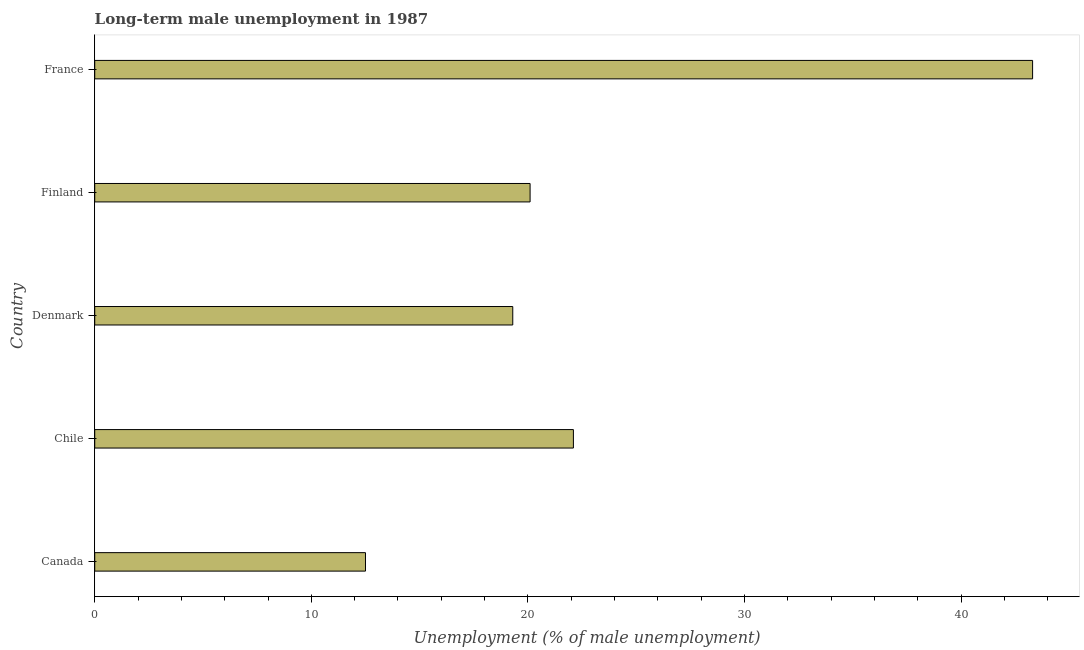Does the graph contain grids?
Your answer should be very brief. No. What is the title of the graph?
Provide a succinct answer. Long-term male unemployment in 1987. What is the label or title of the X-axis?
Provide a short and direct response. Unemployment (% of male unemployment). What is the long-term male unemployment in France?
Make the answer very short. 43.3. Across all countries, what is the maximum long-term male unemployment?
Offer a very short reply. 43.3. Across all countries, what is the minimum long-term male unemployment?
Your response must be concise. 12.5. In which country was the long-term male unemployment minimum?
Give a very brief answer. Canada. What is the sum of the long-term male unemployment?
Keep it short and to the point. 117.3. What is the difference between the long-term male unemployment in Finland and France?
Provide a short and direct response. -23.2. What is the average long-term male unemployment per country?
Offer a very short reply. 23.46. What is the median long-term male unemployment?
Offer a very short reply. 20.1. What is the ratio of the long-term male unemployment in Finland to that in France?
Ensure brevity in your answer.  0.46. Is the long-term male unemployment in Finland less than that in France?
Make the answer very short. Yes. What is the difference between the highest and the second highest long-term male unemployment?
Give a very brief answer. 21.2. What is the difference between the highest and the lowest long-term male unemployment?
Keep it short and to the point. 30.8. How many bars are there?
Your answer should be very brief. 5. How many countries are there in the graph?
Your answer should be compact. 5. What is the difference between two consecutive major ticks on the X-axis?
Make the answer very short. 10. What is the Unemployment (% of male unemployment) of Canada?
Make the answer very short. 12.5. What is the Unemployment (% of male unemployment) in Chile?
Offer a very short reply. 22.1. What is the Unemployment (% of male unemployment) in Denmark?
Keep it short and to the point. 19.3. What is the Unemployment (% of male unemployment) of Finland?
Ensure brevity in your answer.  20.1. What is the Unemployment (% of male unemployment) in France?
Your answer should be compact. 43.3. What is the difference between the Unemployment (% of male unemployment) in Canada and Chile?
Your response must be concise. -9.6. What is the difference between the Unemployment (% of male unemployment) in Canada and Denmark?
Offer a terse response. -6.8. What is the difference between the Unemployment (% of male unemployment) in Canada and Finland?
Give a very brief answer. -7.6. What is the difference between the Unemployment (% of male unemployment) in Canada and France?
Your answer should be compact. -30.8. What is the difference between the Unemployment (% of male unemployment) in Chile and Denmark?
Provide a succinct answer. 2.8. What is the difference between the Unemployment (% of male unemployment) in Chile and France?
Offer a terse response. -21.2. What is the difference between the Unemployment (% of male unemployment) in Denmark and Finland?
Offer a terse response. -0.8. What is the difference between the Unemployment (% of male unemployment) in Denmark and France?
Your answer should be compact. -24. What is the difference between the Unemployment (% of male unemployment) in Finland and France?
Ensure brevity in your answer.  -23.2. What is the ratio of the Unemployment (% of male unemployment) in Canada to that in Chile?
Give a very brief answer. 0.57. What is the ratio of the Unemployment (% of male unemployment) in Canada to that in Denmark?
Ensure brevity in your answer.  0.65. What is the ratio of the Unemployment (% of male unemployment) in Canada to that in Finland?
Provide a succinct answer. 0.62. What is the ratio of the Unemployment (% of male unemployment) in Canada to that in France?
Ensure brevity in your answer.  0.29. What is the ratio of the Unemployment (% of male unemployment) in Chile to that in Denmark?
Ensure brevity in your answer.  1.15. What is the ratio of the Unemployment (% of male unemployment) in Chile to that in Finland?
Provide a succinct answer. 1.1. What is the ratio of the Unemployment (% of male unemployment) in Chile to that in France?
Ensure brevity in your answer.  0.51. What is the ratio of the Unemployment (% of male unemployment) in Denmark to that in Finland?
Provide a succinct answer. 0.96. What is the ratio of the Unemployment (% of male unemployment) in Denmark to that in France?
Your response must be concise. 0.45. What is the ratio of the Unemployment (% of male unemployment) in Finland to that in France?
Your answer should be compact. 0.46. 